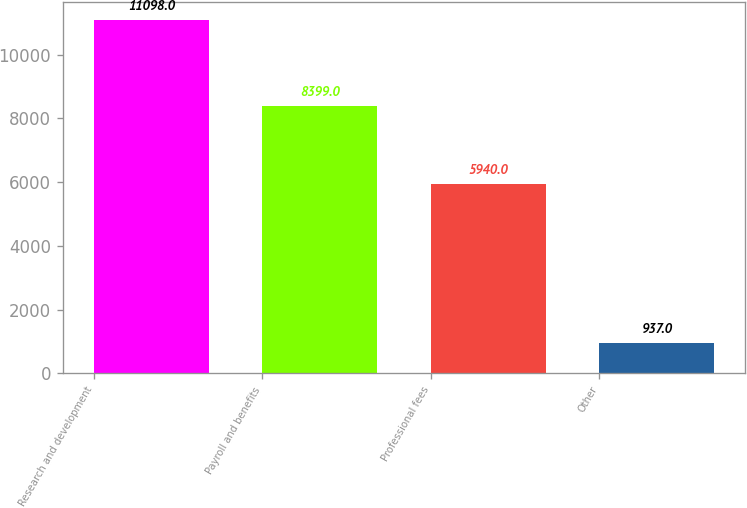Convert chart. <chart><loc_0><loc_0><loc_500><loc_500><bar_chart><fcel>Research and development<fcel>Payroll and benefits<fcel>Professional fees<fcel>Other<nl><fcel>11098<fcel>8399<fcel>5940<fcel>937<nl></chart> 